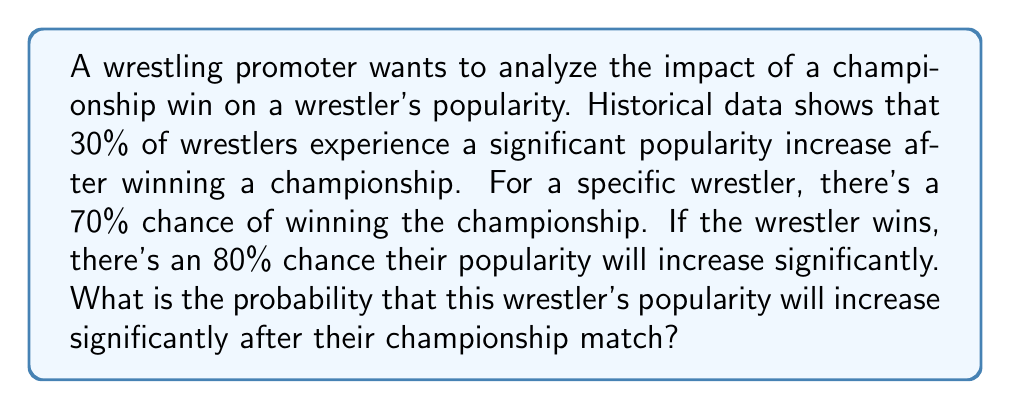Help me with this question. Let's approach this problem using Bayesian inference:

1) Define our events:
   W: Wrestler wins the championship
   P: Wrestler's popularity increases significantly

2) Given probabilities:
   P(W) = 0.70 (probability of winning)
   P(P|W) = 0.80 (probability of popularity increase given a win)
   P(P) = 0.30 (overall probability of popularity increase)

3) We want to find P(P), which we can calculate using the law of total probability:

   $$P(P) = P(P|W)P(W) + P(P|\text{not }W)P(\text{not }W)$$

4) We know P(P|W), P(W), and P(P). Let's solve for P(P|not W):

   $$0.30 = 0.80 * 0.70 + P(P|\text{not }W) * 0.30$$
   $$0.30 = 0.56 + 0.30P(P|\text{not }W)$$
   $$-0.26 = 0.30P(P|\text{not }W)$$
   $$P(P|\text{not }W) = -0.8667$$

5) Now we can calculate the probability of a popularity increase:

   $$P(P) = P(P|W)P(W) + P(P|\text{not }W)P(\text{not }W)$$
   $$P(P) = 0.80 * 0.70 + (-0.8667) * 0.30$$
   $$P(P) = 0.56 - 0.26$$
   $$P(P) = 0.30$$

Therefore, the probability that this wrestler's popularity will increase significantly after their championship match is 0.30 or 30%.
Answer: 0.30 or 30% 